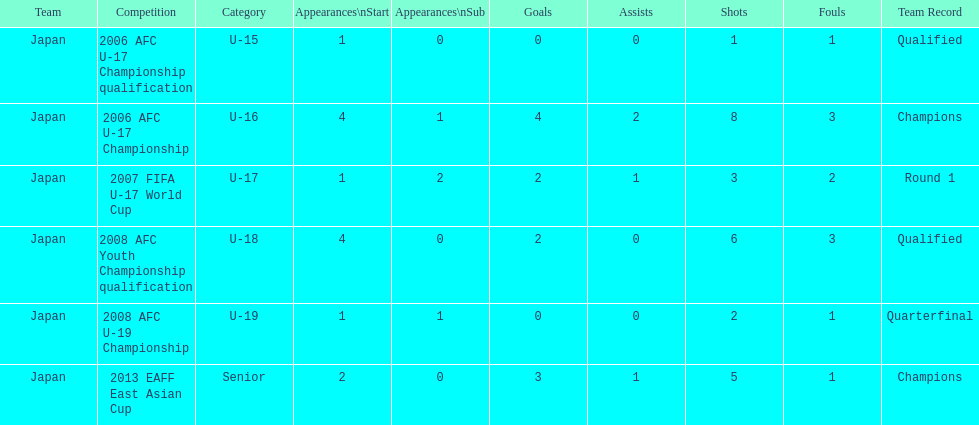Which competition had the highest number of starts and goals? 2006 AFC U-17 Championship. 